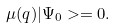Convert formula to latex. <formula><loc_0><loc_0><loc_500><loc_500>\mu ( q ) | \Psi _ { 0 } > = 0 .</formula> 